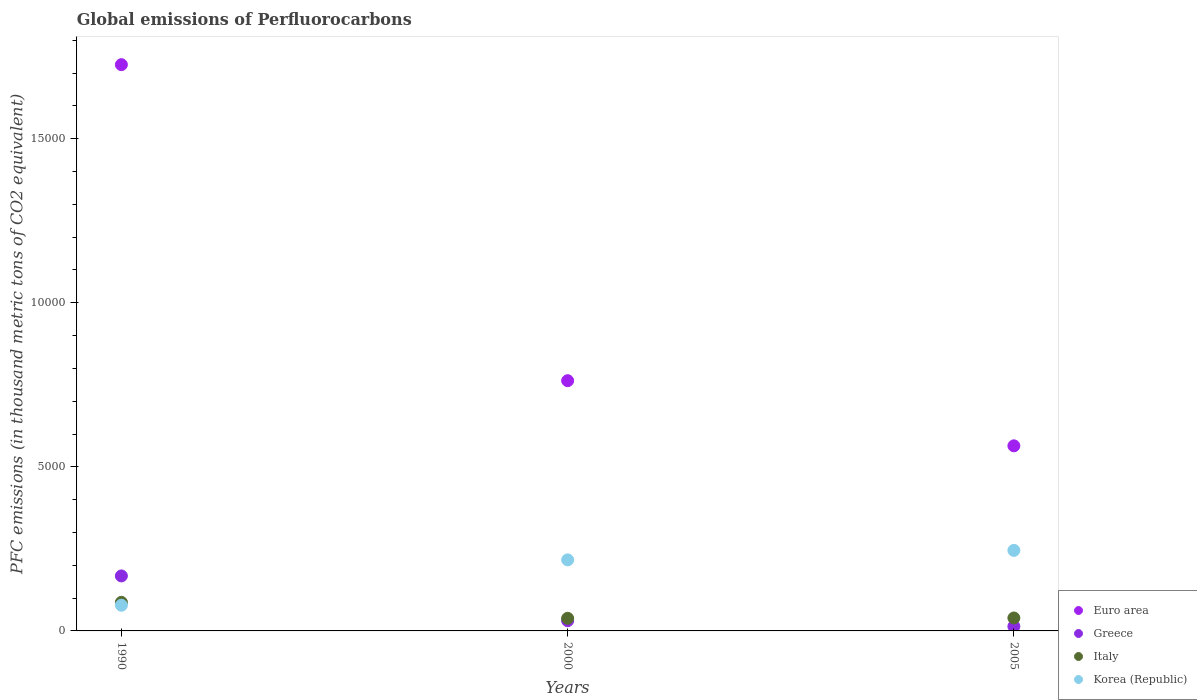How many different coloured dotlines are there?
Offer a terse response. 4. Is the number of dotlines equal to the number of legend labels?
Provide a succinct answer. Yes. What is the global emissions of Perfluorocarbons in Euro area in 1990?
Your answer should be very brief. 1.73e+04. Across all years, what is the maximum global emissions of Perfluorocarbons in Greece?
Offer a very short reply. 1675.9. Across all years, what is the minimum global emissions of Perfluorocarbons in Korea (Republic)?
Keep it short and to the point. 782.6. What is the total global emissions of Perfluorocarbons in Euro area in the graph?
Make the answer very short. 3.05e+04. What is the difference between the global emissions of Perfluorocarbons in Korea (Republic) in 1990 and that in 2000?
Give a very brief answer. -1382.3. What is the difference between the global emissions of Perfluorocarbons in Greece in 1990 and the global emissions of Perfluorocarbons in Euro area in 2005?
Make the answer very short. -3964.16. What is the average global emissions of Perfluorocarbons in Greece per year?
Keep it short and to the point. 708.23. In the year 2005, what is the difference between the global emissions of Perfluorocarbons in Greece and global emissions of Perfluorocarbons in Korea (Republic)?
Offer a very short reply. -2316.2. What is the ratio of the global emissions of Perfluorocarbons in Korea (Republic) in 1990 to that in 2000?
Provide a succinct answer. 0.36. Is the global emissions of Perfluorocarbons in Italy in 1990 less than that in 2000?
Ensure brevity in your answer.  No. Is the difference between the global emissions of Perfluorocarbons in Greece in 1990 and 2005 greater than the difference between the global emissions of Perfluorocarbons in Korea (Republic) in 1990 and 2005?
Make the answer very short. Yes. What is the difference between the highest and the second highest global emissions of Perfluorocarbons in Greece?
Make the answer very short. 1364.6. What is the difference between the highest and the lowest global emissions of Perfluorocarbons in Greece?
Ensure brevity in your answer.  1538.4. Is the sum of the global emissions of Perfluorocarbons in Euro area in 1990 and 2005 greater than the maximum global emissions of Perfluorocarbons in Greece across all years?
Give a very brief answer. Yes. Is it the case that in every year, the sum of the global emissions of Perfluorocarbons in Greece and global emissions of Perfluorocarbons in Italy  is greater than the global emissions of Perfluorocarbons in Euro area?
Ensure brevity in your answer.  No. Does the global emissions of Perfluorocarbons in Greece monotonically increase over the years?
Your answer should be compact. No. How many years are there in the graph?
Make the answer very short. 3. What is the difference between two consecutive major ticks on the Y-axis?
Your response must be concise. 5000. Does the graph contain any zero values?
Your answer should be very brief. No. How are the legend labels stacked?
Your response must be concise. Vertical. What is the title of the graph?
Provide a short and direct response. Global emissions of Perfluorocarbons. Does "St. Lucia" appear as one of the legend labels in the graph?
Give a very brief answer. No. What is the label or title of the Y-axis?
Your response must be concise. PFC emissions (in thousand metric tons of CO2 equivalent). What is the PFC emissions (in thousand metric tons of CO2 equivalent) of Euro area in 1990?
Your answer should be very brief. 1.73e+04. What is the PFC emissions (in thousand metric tons of CO2 equivalent) of Greece in 1990?
Your answer should be compact. 1675.9. What is the PFC emissions (in thousand metric tons of CO2 equivalent) of Italy in 1990?
Keep it short and to the point. 871. What is the PFC emissions (in thousand metric tons of CO2 equivalent) in Korea (Republic) in 1990?
Make the answer very short. 782.6. What is the PFC emissions (in thousand metric tons of CO2 equivalent) of Euro area in 2000?
Ensure brevity in your answer.  7625. What is the PFC emissions (in thousand metric tons of CO2 equivalent) in Greece in 2000?
Your response must be concise. 311.3. What is the PFC emissions (in thousand metric tons of CO2 equivalent) of Italy in 2000?
Your answer should be compact. 384.3. What is the PFC emissions (in thousand metric tons of CO2 equivalent) in Korea (Republic) in 2000?
Your response must be concise. 2164.9. What is the PFC emissions (in thousand metric tons of CO2 equivalent) in Euro area in 2005?
Your answer should be compact. 5640.06. What is the PFC emissions (in thousand metric tons of CO2 equivalent) of Greece in 2005?
Make the answer very short. 137.5. What is the PFC emissions (in thousand metric tons of CO2 equivalent) in Italy in 2005?
Offer a terse response. 394.3. What is the PFC emissions (in thousand metric tons of CO2 equivalent) in Korea (Republic) in 2005?
Your answer should be very brief. 2453.7. Across all years, what is the maximum PFC emissions (in thousand metric tons of CO2 equivalent) of Euro area?
Offer a terse response. 1.73e+04. Across all years, what is the maximum PFC emissions (in thousand metric tons of CO2 equivalent) of Greece?
Your answer should be very brief. 1675.9. Across all years, what is the maximum PFC emissions (in thousand metric tons of CO2 equivalent) in Italy?
Give a very brief answer. 871. Across all years, what is the maximum PFC emissions (in thousand metric tons of CO2 equivalent) in Korea (Republic)?
Keep it short and to the point. 2453.7. Across all years, what is the minimum PFC emissions (in thousand metric tons of CO2 equivalent) in Euro area?
Provide a short and direct response. 5640.06. Across all years, what is the minimum PFC emissions (in thousand metric tons of CO2 equivalent) in Greece?
Provide a succinct answer. 137.5. Across all years, what is the minimum PFC emissions (in thousand metric tons of CO2 equivalent) in Italy?
Your answer should be very brief. 384.3. Across all years, what is the minimum PFC emissions (in thousand metric tons of CO2 equivalent) of Korea (Republic)?
Offer a very short reply. 782.6. What is the total PFC emissions (in thousand metric tons of CO2 equivalent) of Euro area in the graph?
Ensure brevity in your answer.  3.05e+04. What is the total PFC emissions (in thousand metric tons of CO2 equivalent) in Greece in the graph?
Your response must be concise. 2124.7. What is the total PFC emissions (in thousand metric tons of CO2 equivalent) of Italy in the graph?
Offer a very short reply. 1649.6. What is the total PFC emissions (in thousand metric tons of CO2 equivalent) of Korea (Republic) in the graph?
Your answer should be compact. 5401.2. What is the difference between the PFC emissions (in thousand metric tons of CO2 equivalent) in Euro area in 1990 and that in 2000?
Make the answer very short. 9630.1. What is the difference between the PFC emissions (in thousand metric tons of CO2 equivalent) of Greece in 1990 and that in 2000?
Provide a succinct answer. 1364.6. What is the difference between the PFC emissions (in thousand metric tons of CO2 equivalent) in Italy in 1990 and that in 2000?
Provide a succinct answer. 486.7. What is the difference between the PFC emissions (in thousand metric tons of CO2 equivalent) of Korea (Republic) in 1990 and that in 2000?
Your answer should be very brief. -1382.3. What is the difference between the PFC emissions (in thousand metric tons of CO2 equivalent) in Euro area in 1990 and that in 2005?
Keep it short and to the point. 1.16e+04. What is the difference between the PFC emissions (in thousand metric tons of CO2 equivalent) in Greece in 1990 and that in 2005?
Provide a succinct answer. 1538.4. What is the difference between the PFC emissions (in thousand metric tons of CO2 equivalent) in Italy in 1990 and that in 2005?
Your answer should be compact. 476.7. What is the difference between the PFC emissions (in thousand metric tons of CO2 equivalent) of Korea (Republic) in 1990 and that in 2005?
Make the answer very short. -1671.1. What is the difference between the PFC emissions (in thousand metric tons of CO2 equivalent) in Euro area in 2000 and that in 2005?
Keep it short and to the point. 1984.94. What is the difference between the PFC emissions (in thousand metric tons of CO2 equivalent) in Greece in 2000 and that in 2005?
Offer a very short reply. 173.8. What is the difference between the PFC emissions (in thousand metric tons of CO2 equivalent) in Italy in 2000 and that in 2005?
Ensure brevity in your answer.  -10. What is the difference between the PFC emissions (in thousand metric tons of CO2 equivalent) in Korea (Republic) in 2000 and that in 2005?
Offer a terse response. -288.8. What is the difference between the PFC emissions (in thousand metric tons of CO2 equivalent) in Euro area in 1990 and the PFC emissions (in thousand metric tons of CO2 equivalent) in Greece in 2000?
Offer a very short reply. 1.69e+04. What is the difference between the PFC emissions (in thousand metric tons of CO2 equivalent) of Euro area in 1990 and the PFC emissions (in thousand metric tons of CO2 equivalent) of Italy in 2000?
Your answer should be very brief. 1.69e+04. What is the difference between the PFC emissions (in thousand metric tons of CO2 equivalent) of Euro area in 1990 and the PFC emissions (in thousand metric tons of CO2 equivalent) of Korea (Republic) in 2000?
Offer a terse response. 1.51e+04. What is the difference between the PFC emissions (in thousand metric tons of CO2 equivalent) of Greece in 1990 and the PFC emissions (in thousand metric tons of CO2 equivalent) of Italy in 2000?
Give a very brief answer. 1291.6. What is the difference between the PFC emissions (in thousand metric tons of CO2 equivalent) of Greece in 1990 and the PFC emissions (in thousand metric tons of CO2 equivalent) of Korea (Republic) in 2000?
Offer a very short reply. -489. What is the difference between the PFC emissions (in thousand metric tons of CO2 equivalent) in Italy in 1990 and the PFC emissions (in thousand metric tons of CO2 equivalent) in Korea (Republic) in 2000?
Give a very brief answer. -1293.9. What is the difference between the PFC emissions (in thousand metric tons of CO2 equivalent) of Euro area in 1990 and the PFC emissions (in thousand metric tons of CO2 equivalent) of Greece in 2005?
Give a very brief answer. 1.71e+04. What is the difference between the PFC emissions (in thousand metric tons of CO2 equivalent) in Euro area in 1990 and the PFC emissions (in thousand metric tons of CO2 equivalent) in Italy in 2005?
Provide a short and direct response. 1.69e+04. What is the difference between the PFC emissions (in thousand metric tons of CO2 equivalent) in Euro area in 1990 and the PFC emissions (in thousand metric tons of CO2 equivalent) in Korea (Republic) in 2005?
Give a very brief answer. 1.48e+04. What is the difference between the PFC emissions (in thousand metric tons of CO2 equivalent) in Greece in 1990 and the PFC emissions (in thousand metric tons of CO2 equivalent) in Italy in 2005?
Offer a very short reply. 1281.6. What is the difference between the PFC emissions (in thousand metric tons of CO2 equivalent) in Greece in 1990 and the PFC emissions (in thousand metric tons of CO2 equivalent) in Korea (Republic) in 2005?
Ensure brevity in your answer.  -777.8. What is the difference between the PFC emissions (in thousand metric tons of CO2 equivalent) of Italy in 1990 and the PFC emissions (in thousand metric tons of CO2 equivalent) of Korea (Republic) in 2005?
Your response must be concise. -1582.7. What is the difference between the PFC emissions (in thousand metric tons of CO2 equivalent) in Euro area in 2000 and the PFC emissions (in thousand metric tons of CO2 equivalent) in Greece in 2005?
Give a very brief answer. 7487.5. What is the difference between the PFC emissions (in thousand metric tons of CO2 equivalent) of Euro area in 2000 and the PFC emissions (in thousand metric tons of CO2 equivalent) of Italy in 2005?
Offer a very short reply. 7230.7. What is the difference between the PFC emissions (in thousand metric tons of CO2 equivalent) in Euro area in 2000 and the PFC emissions (in thousand metric tons of CO2 equivalent) in Korea (Republic) in 2005?
Give a very brief answer. 5171.3. What is the difference between the PFC emissions (in thousand metric tons of CO2 equivalent) of Greece in 2000 and the PFC emissions (in thousand metric tons of CO2 equivalent) of Italy in 2005?
Keep it short and to the point. -83. What is the difference between the PFC emissions (in thousand metric tons of CO2 equivalent) in Greece in 2000 and the PFC emissions (in thousand metric tons of CO2 equivalent) in Korea (Republic) in 2005?
Ensure brevity in your answer.  -2142.4. What is the difference between the PFC emissions (in thousand metric tons of CO2 equivalent) of Italy in 2000 and the PFC emissions (in thousand metric tons of CO2 equivalent) of Korea (Republic) in 2005?
Your answer should be very brief. -2069.4. What is the average PFC emissions (in thousand metric tons of CO2 equivalent) in Euro area per year?
Your answer should be compact. 1.02e+04. What is the average PFC emissions (in thousand metric tons of CO2 equivalent) in Greece per year?
Offer a terse response. 708.23. What is the average PFC emissions (in thousand metric tons of CO2 equivalent) of Italy per year?
Provide a short and direct response. 549.87. What is the average PFC emissions (in thousand metric tons of CO2 equivalent) of Korea (Republic) per year?
Provide a succinct answer. 1800.4. In the year 1990, what is the difference between the PFC emissions (in thousand metric tons of CO2 equivalent) in Euro area and PFC emissions (in thousand metric tons of CO2 equivalent) in Greece?
Make the answer very short. 1.56e+04. In the year 1990, what is the difference between the PFC emissions (in thousand metric tons of CO2 equivalent) of Euro area and PFC emissions (in thousand metric tons of CO2 equivalent) of Italy?
Provide a succinct answer. 1.64e+04. In the year 1990, what is the difference between the PFC emissions (in thousand metric tons of CO2 equivalent) of Euro area and PFC emissions (in thousand metric tons of CO2 equivalent) of Korea (Republic)?
Provide a succinct answer. 1.65e+04. In the year 1990, what is the difference between the PFC emissions (in thousand metric tons of CO2 equivalent) in Greece and PFC emissions (in thousand metric tons of CO2 equivalent) in Italy?
Offer a terse response. 804.9. In the year 1990, what is the difference between the PFC emissions (in thousand metric tons of CO2 equivalent) of Greece and PFC emissions (in thousand metric tons of CO2 equivalent) of Korea (Republic)?
Offer a terse response. 893.3. In the year 1990, what is the difference between the PFC emissions (in thousand metric tons of CO2 equivalent) of Italy and PFC emissions (in thousand metric tons of CO2 equivalent) of Korea (Republic)?
Provide a short and direct response. 88.4. In the year 2000, what is the difference between the PFC emissions (in thousand metric tons of CO2 equivalent) in Euro area and PFC emissions (in thousand metric tons of CO2 equivalent) in Greece?
Offer a terse response. 7313.7. In the year 2000, what is the difference between the PFC emissions (in thousand metric tons of CO2 equivalent) of Euro area and PFC emissions (in thousand metric tons of CO2 equivalent) of Italy?
Offer a terse response. 7240.7. In the year 2000, what is the difference between the PFC emissions (in thousand metric tons of CO2 equivalent) of Euro area and PFC emissions (in thousand metric tons of CO2 equivalent) of Korea (Republic)?
Make the answer very short. 5460.1. In the year 2000, what is the difference between the PFC emissions (in thousand metric tons of CO2 equivalent) of Greece and PFC emissions (in thousand metric tons of CO2 equivalent) of Italy?
Provide a succinct answer. -73. In the year 2000, what is the difference between the PFC emissions (in thousand metric tons of CO2 equivalent) in Greece and PFC emissions (in thousand metric tons of CO2 equivalent) in Korea (Republic)?
Give a very brief answer. -1853.6. In the year 2000, what is the difference between the PFC emissions (in thousand metric tons of CO2 equivalent) of Italy and PFC emissions (in thousand metric tons of CO2 equivalent) of Korea (Republic)?
Provide a short and direct response. -1780.6. In the year 2005, what is the difference between the PFC emissions (in thousand metric tons of CO2 equivalent) in Euro area and PFC emissions (in thousand metric tons of CO2 equivalent) in Greece?
Your answer should be very brief. 5502.56. In the year 2005, what is the difference between the PFC emissions (in thousand metric tons of CO2 equivalent) in Euro area and PFC emissions (in thousand metric tons of CO2 equivalent) in Italy?
Your answer should be compact. 5245.76. In the year 2005, what is the difference between the PFC emissions (in thousand metric tons of CO2 equivalent) in Euro area and PFC emissions (in thousand metric tons of CO2 equivalent) in Korea (Republic)?
Ensure brevity in your answer.  3186.36. In the year 2005, what is the difference between the PFC emissions (in thousand metric tons of CO2 equivalent) of Greece and PFC emissions (in thousand metric tons of CO2 equivalent) of Italy?
Give a very brief answer. -256.8. In the year 2005, what is the difference between the PFC emissions (in thousand metric tons of CO2 equivalent) of Greece and PFC emissions (in thousand metric tons of CO2 equivalent) of Korea (Republic)?
Your answer should be very brief. -2316.2. In the year 2005, what is the difference between the PFC emissions (in thousand metric tons of CO2 equivalent) in Italy and PFC emissions (in thousand metric tons of CO2 equivalent) in Korea (Republic)?
Your answer should be compact. -2059.4. What is the ratio of the PFC emissions (in thousand metric tons of CO2 equivalent) in Euro area in 1990 to that in 2000?
Offer a terse response. 2.26. What is the ratio of the PFC emissions (in thousand metric tons of CO2 equivalent) in Greece in 1990 to that in 2000?
Offer a terse response. 5.38. What is the ratio of the PFC emissions (in thousand metric tons of CO2 equivalent) of Italy in 1990 to that in 2000?
Your answer should be compact. 2.27. What is the ratio of the PFC emissions (in thousand metric tons of CO2 equivalent) in Korea (Republic) in 1990 to that in 2000?
Offer a very short reply. 0.36. What is the ratio of the PFC emissions (in thousand metric tons of CO2 equivalent) in Euro area in 1990 to that in 2005?
Your answer should be very brief. 3.06. What is the ratio of the PFC emissions (in thousand metric tons of CO2 equivalent) of Greece in 1990 to that in 2005?
Keep it short and to the point. 12.19. What is the ratio of the PFC emissions (in thousand metric tons of CO2 equivalent) in Italy in 1990 to that in 2005?
Your response must be concise. 2.21. What is the ratio of the PFC emissions (in thousand metric tons of CO2 equivalent) in Korea (Republic) in 1990 to that in 2005?
Keep it short and to the point. 0.32. What is the ratio of the PFC emissions (in thousand metric tons of CO2 equivalent) in Euro area in 2000 to that in 2005?
Provide a succinct answer. 1.35. What is the ratio of the PFC emissions (in thousand metric tons of CO2 equivalent) in Greece in 2000 to that in 2005?
Provide a succinct answer. 2.26. What is the ratio of the PFC emissions (in thousand metric tons of CO2 equivalent) in Italy in 2000 to that in 2005?
Keep it short and to the point. 0.97. What is the ratio of the PFC emissions (in thousand metric tons of CO2 equivalent) of Korea (Republic) in 2000 to that in 2005?
Make the answer very short. 0.88. What is the difference between the highest and the second highest PFC emissions (in thousand metric tons of CO2 equivalent) of Euro area?
Provide a succinct answer. 9630.1. What is the difference between the highest and the second highest PFC emissions (in thousand metric tons of CO2 equivalent) in Greece?
Keep it short and to the point. 1364.6. What is the difference between the highest and the second highest PFC emissions (in thousand metric tons of CO2 equivalent) of Italy?
Your answer should be compact. 476.7. What is the difference between the highest and the second highest PFC emissions (in thousand metric tons of CO2 equivalent) of Korea (Republic)?
Your answer should be very brief. 288.8. What is the difference between the highest and the lowest PFC emissions (in thousand metric tons of CO2 equivalent) of Euro area?
Your answer should be very brief. 1.16e+04. What is the difference between the highest and the lowest PFC emissions (in thousand metric tons of CO2 equivalent) of Greece?
Your answer should be compact. 1538.4. What is the difference between the highest and the lowest PFC emissions (in thousand metric tons of CO2 equivalent) of Italy?
Ensure brevity in your answer.  486.7. What is the difference between the highest and the lowest PFC emissions (in thousand metric tons of CO2 equivalent) of Korea (Republic)?
Keep it short and to the point. 1671.1. 